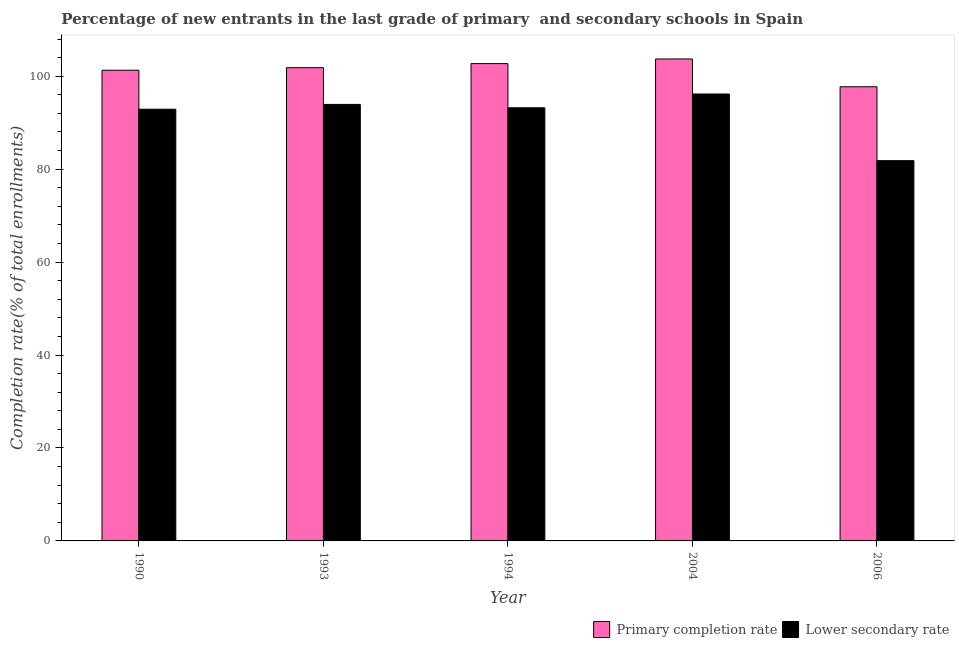How many groups of bars are there?
Make the answer very short. 5. Are the number of bars per tick equal to the number of legend labels?
Keep it short and to the point. Yes. How many bars are there on the 4th tick from the left?
Keep it short and to the point. 2. How many bars are there on the 1st tick from the right?
Give a very brief answer. 2. What is the label of the 5th group of bars from the left?
Give a very brief answer. 2006. What is the completion rate in primary schools in 2006?
Your response must be concise. 97.73. Across all years, what is the maximum completion rate in primary schools?
Make the answer very short. 103.71. Across all years, what is the minimum completion rate in secondary schools?
Provide a succinct answer. 81.83. What is the total completion rate in primary schools in the graph?
Provide a short and direct response. 507.29. What is the difference between the completion rate in primary schools in 1993 and that in 2004?
Offer a terse response. -1.88. What is the difference between the completion rate in primary schools in 1993 and the completion rate in secondary schools in 2006?
Your answer should be very brief. 4.1. What is the average completion rate in primary schools per year?
Your response must be concise. 101.46. What is the ratio of the completion rate in secondary schools in 1990 to that in 2006?
Provide a short and direct response. 1.14. Is the completion rate in primary schools in 1990 less than that in 1994?
Offer a very short reply. Yes. What is the difference between the highest and the second highest completion rate in secondary schools?
Ensure brevity in your answer.  2.24. What is the difference between the highest and the lowest completion rate in primary schools?
Provide a short and direct response. 5.98. In how many years, is the completion rate in secondary schools greater than the average completion rate in secondary schools taken over all years?
Your response must be concise. 4. What does the 1st bar from the left in 2006 represents?
Provide a short and direct response. Primary completion rate. What does the 1st bar from the right in 2004 represents?
Ensure brevity in your answer.  Lower secondary rate. Are all the bars in the graph horizontal?
Your answer should be very brief. No. What is the difference between two consecutive major ticks on the Y-axis?
Ensure brevity in your answer.  20. Are the values on the major ticks of Y-axis written in scientific E-notation?
Keep it short and to the point. No. Does the graph contain any zero values?
Make the answer very short. No. How are the legend labels stacked?
Give a very brief answer. Horizontal. What is the title of the graph?
Offer a very short reply. Percentage of new entrants in the last grade of primary  and secondary schools in Spain. Does "Agricultural land" appear as one of the legend labels in the graph?
Your response must be concise. No. What is the label or title of the Y-axis?
Your answer should be compact. Completion rate(% of total enrollments). What is the Completion rate(% of total enrollments) of Primary completion rate in 1990?
Offer a terse response. 101.29. What is the Completion rate(% of total enrollments) in Lower secondary rate in 1990?
Offer a very short reply. 92.9. What is the Completion rate(% of total enrollments) in Primary completion rate in 1993?
Offer a terse response. 101.84. What is the Completion rate(% of total enrollments) in Lower secondary rate in 1993?
Offer a terse response. 93.93. What is the Completion rate(% of total enrollments) in Primary completion rate in 1994?
Your answer should be very brief. 102.72. What is the Completion rate(% of total enrollments) in Lower secondary rate in 1994?
Give a very brief answer. 93.21. What is the Completion rate(% of total enrollments) of Primary completion rate in 2004?
Provide a succinct answer. 103.71. What is the Completion rate(% of total enrollments) in Lower secondary rate in 2004?
Give a very brief answer. 96.17. What is the Completion rate(% of total enrollments) in Primary completion rate in 2006?
Your response must be concise. 97.73. What is the Completion rate(% of total enrollments) of Lower secondary rate in 2006?
Keep it short and to the point. 81.83. Across all years, what is the maximum Completion rate(% of total enrollments) of Primary completion rate?
Give a very brief answer. 103.71. Across all years, what is the maximum Completion rate(% of total enrollments) in Lower secondary rate?
Give a very brief answer. 96.17. Across all years, what is the minimum Completion rate(% of total enrollments) in Primary completion rate?
Offer a terse response. 97.73. Across all years, what is the minimum Completion rate(% of total enrollments) of Lower secondary rate?
Make the answer very short. 81.83. What is the total Completion rate(% of total enrollments) in Primary completion rate in the graph?
Your answer should be compact. 507.29. What is the total Completion rate(% of total enrollments) in Lower secondary rate in the graph?
Offer a terse response. 458.05. What is the difference between the Completion rate(% of total enrollments) in Primary completion rate in 1990 and that in 1993?
Your answer should be compact. -0.55. What is the difference between the Completion rate(% of total enrollments) in Lower secondary rate in 1990 and that in 1993?
Offer a terse response. -1.03. What is the difference between the Completion rate(% of total enrollments) in Primary completion rate in 1990 and that in 1994?
Give a very brief answer. -1.42. What is the difference between the Completion rate(% of total enrollments) of Lower secondary rate in 1990 and that in 1994?
Provide a succinct answer. -0.31. What is the difference between the Completion rate(% of total enrollments) of Primary completion rate in 1990 and that in 2004?
Keep it short and to the point. -2.42. What is the difference between the Completion rate(% of total enrollments) of Lower secondary rate in 1990 and that in 2004?
Your answer should be compact. -3.28. What is the difference between the Completion rate(% of total enrollments) of Primary completion rate in 1990 and that in 2006?
Offer a very short reply. 3.56. What is the difference between the Completion rate(% of total enrollments) in Lower secondary rate in 1990 and that in 2006?
Provide a succinct answer. 11.06. What is the difference between the Completion rate(% of total enrollments) in Primary completion rate in 1993 and that in 1994?
Your answer should be very brief. -0.88. What is the difference between the Completion rate(% of total enrollments) of Lower secondary rate in 1993 and that in 1994?
Your answer should be very brief. 0.72. What is the difference between the Completion rate(% of total enrollments) in Primary completion rate in 1993 and that in 2004?
Your response must be concise. -1.88. What is the difference between the Completion rate(% of total enrollments) in Lower secondary rate in 1993 and that in 2004?
Offer a very short reply. -2.24. What is the difference between the Completion rate(% of total enrollments) of Primary completion rate in 1993 and that in 2006?
Your response must be concise. 4.1. What is the difference between the Completion rate(% of total enrollments) in Lower secondary rate in 1993 and that in 2006?
Your response must be concise. 12.1. What is the difference between the Completion rate(% of total enrollments) of Primary completion rate in 1994 and that in 2004?
Offer a very short reply. -1. What is the difference between the Completion rate(% of total enrollments) of Lower secondary rate in 1994 and that in 2004?
Your answer should be very brief. -2.96. What is the difference between the Completion rate(% of total enrollments) in Primary completion rate in 1994 and that in 2006?
Ensure brevity in your answer.  4.98. What is the difference between the Completion rate(% of total enrollments) of Lower secondary rate in 1994 and that in 2006?
Make the answer very short. 11.38. What is the difference between the Completion rate(% of total enrollments) of Primary completion rate in 2004 and that in 2006?
Your answer should be compact. 5.98. What is the difference between the Completion rate(% of total enrollments) of Lower secondary rate in 2004 and that in 2006?
Give a very brief answer. 14.34. What is the difference between the Completion rate(% of total enrollments) of Primary completion rate in 1990 and the Completion rate(% of total enrollments) of Lower secondary rate in 1993?
Keep it short and to the point. 7.36. What is the difference between the Completion rate(% of total enrollments) of Primary completion rate in 1990 and the Completion rate(% of total enrollments) of Lower secondary rate in 1994?
Make the answer very short. 8.08. What is the difference between the Completion rate(% of total enrollments) in Primary completion rate in 1990 and the Completion rate(% of total enrollments) in Lower secondary rate in 2004?
Offer a very short reply. 5.12. What is the difference between the Completion rate(% of total enrollments) of Primary completion rate in 1990 and the Completion rate(% of total enrollments) of Lower secondary rate in 2006?
Make the answer very short. 19.46. What is the difference between the Completion rate(% of total enrollments) in Primary completion rate in 1993 and the Completion rate(% of total enrollments) in Lower secondary rate in 1994?
Offer a terse response. 8.63. What is the difference between the Completion rate(% of total enrollments) of Primary completion rate in 1993 and the Completion rate(% of total enrollments) of Lower secondary rate in 2004?
Your answer should be very brief. 5.66. What is the difference between the Completion rate(% of total enrollments) of Primary completion rate in 1993 and the Completion rate(% of total enrollments) of Lower secondary rate in 2006?
Provide a short and direct response. 20. What is the difference between the Completion rate(% of total enrollments) of Primary completion rate in 1994 and the Completion rate(% of total enrollments) of Lower secondary rate in 2004?
Your response must be concise. 6.54. What is the difference between the Completion rate(% of total enrollments) in Primary completion rate in 1994 and the Completion rate(% of total enrollments) in Lower secondary rate in 2006?
Ensure brevity in your answer.  20.88. What is the difference between the Completion rate(% of total enrollments) of Primary completion rate in 2004 and the Completion rate(% of total enrollments) of Lower secondary rate in 2006?
Your answer should be very brief. 21.88. What is the average Completion rate(% of total enrollments) in Primary completion rate per year?
Ensure brevity in your answer.  101.46. What is the average Completion rate(% of total enrollments) of Lower secondary rate per year?
Keep it short and to the point. 91.61. In the year 1990, what is the difference between the Completion rate(% of total enrollments) of Primary completion rate and Completion rate(% of total enrollments) of Lower secondary rate?
Ensure brevity in your answer.  8.39. In the year 1993, what is the difference between the Completion rate(% of total enrollments) of Primary completion rate and Completion rate(% of total enrollments) of Lower secondary rate?
Provide a succinct answer. 7.9. In the year 1994, what is the difference between the Completion rate(% of total enrollments) of Primary completion rate and Completion rate(% of total enrollments) of Lower secondary rate?
Ensure brevity in your answer.  9.5. In the year 2004, what is the difference between the Completion rate(% of total enrollments) of Primary completion rate and Completion rate(% of total enrollments) of Lower secondary rate?
Your answer should be compact. 7.54. In the year 2006, what is the difference between the Completion rate(% of total enrollments) of Primary completion rate and Completion rate(% of total enrollments) of Lower secondary rate?
Ensure brevity in your answer.  15.9. What is the ratio of the Completion rate(% of total enrollments) of Primary completion rate in 1990 to that in 1994?
Give a very brief answer. 0.99. What is the ratio of the Completion rate(% of total enrollments) in Lower secondary rate in 1990 to that in 1994?
Provide a succinct answer. 1. What is the ratio of the Completion rate(% of total enrollments) of Primary completion rate in 1990 to that in 2004?
Make the answer very short. 0.98. What is the ratio of the Completion rate(% of total enrollments) in Lower secondary rate in 1990 to that in 2004?
Offer a terse response. 0.97. What is the ratio of the Completion rate(% of total enrollments) in Primary completion rate in 1990 to that in 2006?
Provide a short and direct response. 1.04. What is the ratio of the Completion rate(% of total enrollments) in Lower secondary rate in 1990 to that in 2006?
Provide a succinct answer. 1.14. What is the ratio of the Completion rate(% of total enrollments) of Lower secondary rate in 1993 to that in 1994?
Offer a terse response. 1.01. What is the ratio of the Completion rate(% of total enrollments) in Primary completion rate in 1993 to that in 2004?
Offer a terse response. 0.98. What is the ratio of the Completion rate(% of total enrollments) in Lower secondary rate in 1993 to that in 2004?
Your answer should be compact. 0.98. What is the ratio of the Completion rate(% of total enrollments) in Primary completion rate in 1993 to that in 2006?
Offer a very short reply. 1.04. What is the ratio of the Completion rate(% of total enrollments) of Lower secondary rate in 1993 to that in 2006?
Make the answer very short. 1.15. What is the ratio of the Completion rate(% of total enrollments) of Lower secondary rate in 1994 to that in 2004?
Keep it short and to the point. 0.97. What is the ratio of the Completion rate(% of total enrollments) of Primary completion rate in 1994 to that in 2006?
Your response must be concise. 1.05. What is the ratio of the Completion rate(% of total enrollments) in Lower secondary rate in 1994 to that in 2006?
Give a very brief answer. 1.14. What is the ratio of the Completion rate(% of total enrollments) of Primary completion rate in 2004 to that in 2006?
Give a very brief answer. 1.06. What is the ratio of the Completion rate(% of total enrollments) in Lower secondary rate in 2004 to that in 2006?
Provide a succinct answer. 1.18. What is the difference between the highest and the second highest Completion rate(% of total enrollments) in Lower secondary rate?
Provide a succinct answer. 2.24. What is the difference between the highest and the lowest Completion rate(% of total enrollments) in Primary completion rate?
Provide a short and direct response. 5.98. What is the difference between the highest and the lowest Completion rate(% of total enrollments) in Lower secondary rate?
Your answer should be very brief. 14.34. 